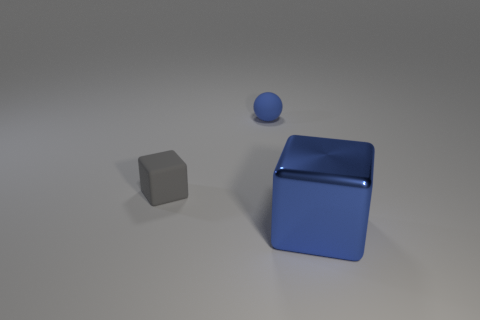Add 3 big gray objects. How many objects exist? 6 Subtract all blocks. How many objects are left? 1 Add 3 blocks. How many blocks exist? 5 Subtract 0 brown cubes. How many objects are left? 3 Subtract all small gray rubber blocks. Subtract all tiny blue matte objects. How many objects are left? 1 Add 3 balls. How many balls are left? 4 